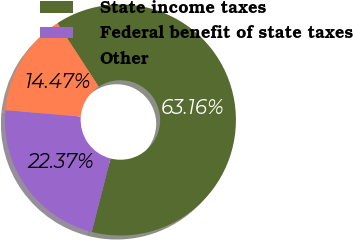Convert chart to OTSL. <chart><loc_0><loc_0><loc_500><loc_500><pie_chart><fcel>State income taxes<fcel>Federal benefit of state taxes<fcel>Other<nl><fcel>63.16%<fcel>22.37%<fcel>14.47%<nl></chart> 